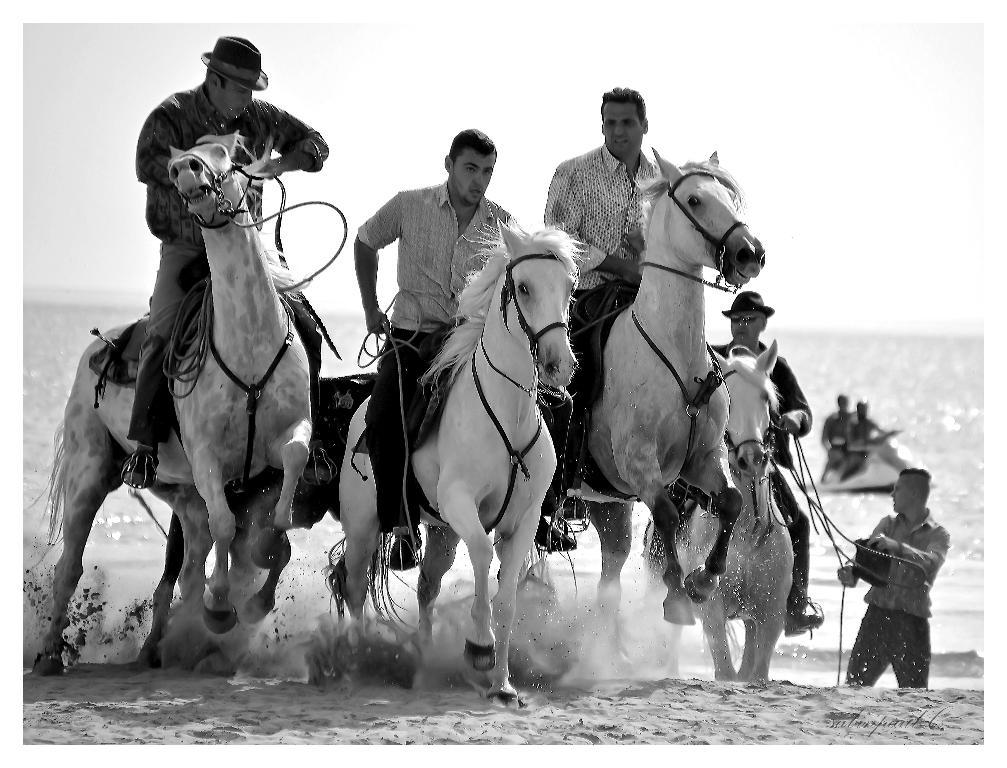What are the persons in the image doing? The persons in the image are riding horses. Can you describe the activity of the persons in the background of the image? There are two persons on water bikes in the background of the image. What type of environment is visible in the image? There is water visible in the image. What type of flower is being used as a power source for the horses in the image? There are no flowers present in the image, and the horses are not powered by any external source. 